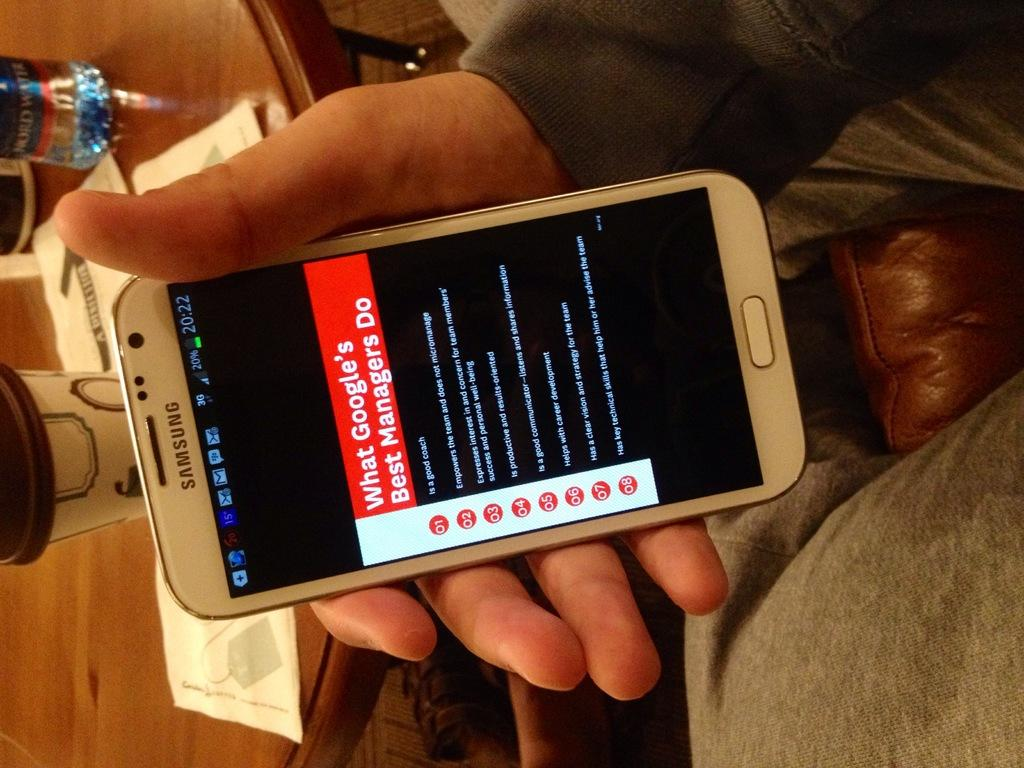<image>
Describe the image concisely. A person holding a white Samsung smartphone with a Google Managers activity list on screen. 